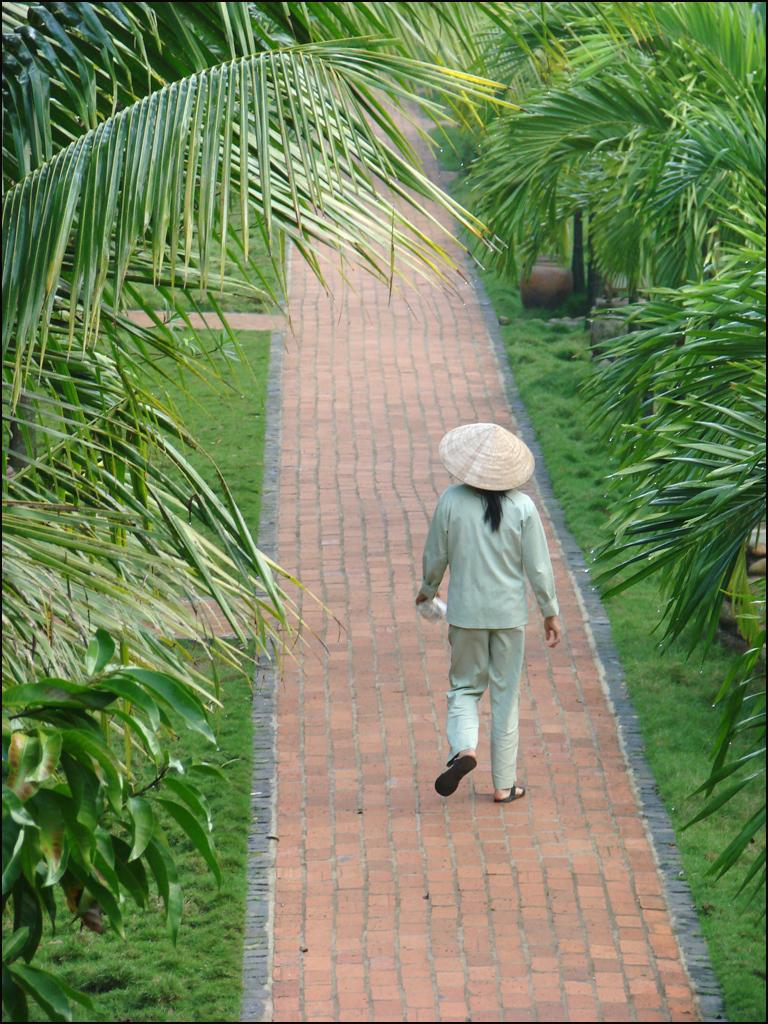Who is the main subject in the image? There is a person in the center of the image. What is the person doing in the image? The person is walking. What accessory is the person wearing in the image? The person is wearing a hat. What is the person holding in the image? The person is holding an object. What can be seen in the background of the image? There are trees in the background of the image. What type of surface is the person walking on in the image? There is a sidewalk at the bottom of the image. What type of chicken can be seen crossing the train tracks in the image? There is no chicken or train tracks present in the image; it features a person walking on a sidewalk with trees in the background. 